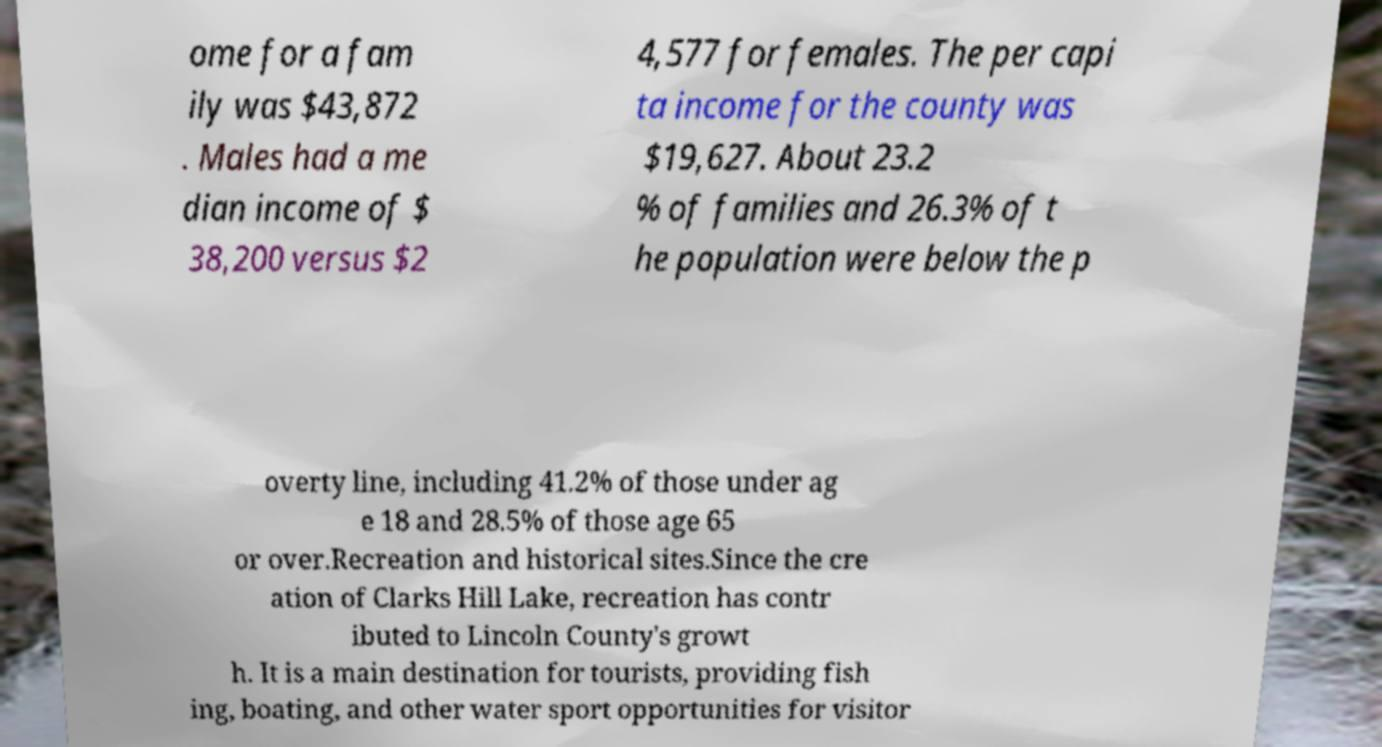Please read and relay the text visible in this image. What does it say? ome for a fam ily was $43,872 . Males had a me dian income of $ 38,200 versus $2 4,577 for females. The per capi ta income for the county was $19,627. About 23.2 % of families and 26.3% of t he population were below the p overty line, including 41.2% of those under ag e 18 and 28.5% of those age 65 or over.Recreation and historical sites.Since the cre ation of Clarks Hill Lake, recreation has contr ibuted to Lincoln County's growt h. It is a main destination for tourists, providing fish ing, boating, and other water sport opportunities for visitor 